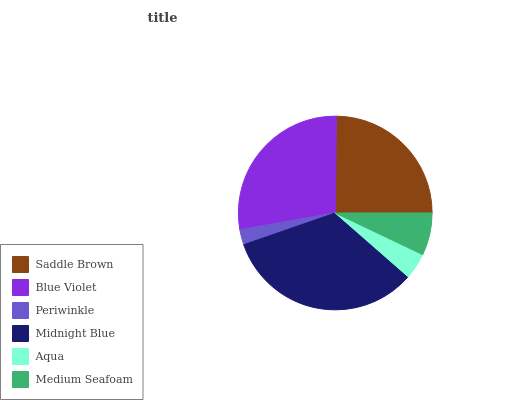Is Periwinkle the minimum?
Answer yes or no. Yes. Is Midnight Blue the maximum?
Answer yes or no. Yes. Is Blue Violet the minimum?
Answer yes or no. No. Is Blue Violet the maximum?
Answer yes or no. No. Is Blue Violet greater than Saddle Brown?
Answer yes or no. Yes. Is Saddle Brown less than Blue Violet?
Answer yes or no. Yes. Is Saddle Brown greater than Blue Violet?
Answer yes or no. No. Is Blue Violet less than Saddle Brown?
Answer yes or no. No. Is Saddle Brown the high median?
Answer yes or no. Yes. Is Medium Seafoam the low median?
Answer yes or no. Yes. Is Midnight Blue the high median?
Answer yes or no. No. Is Saddle Brown the low median?
Answer yes or no. No. 